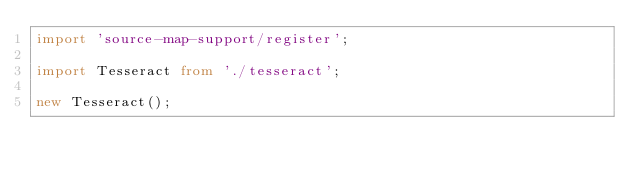<code> <loc_0><loc_0><loc_500><loc_500><_TypeScript_>import 'source-map-support/register';

import Tesseract from './tesseract';

new Tesseract();
</code> 